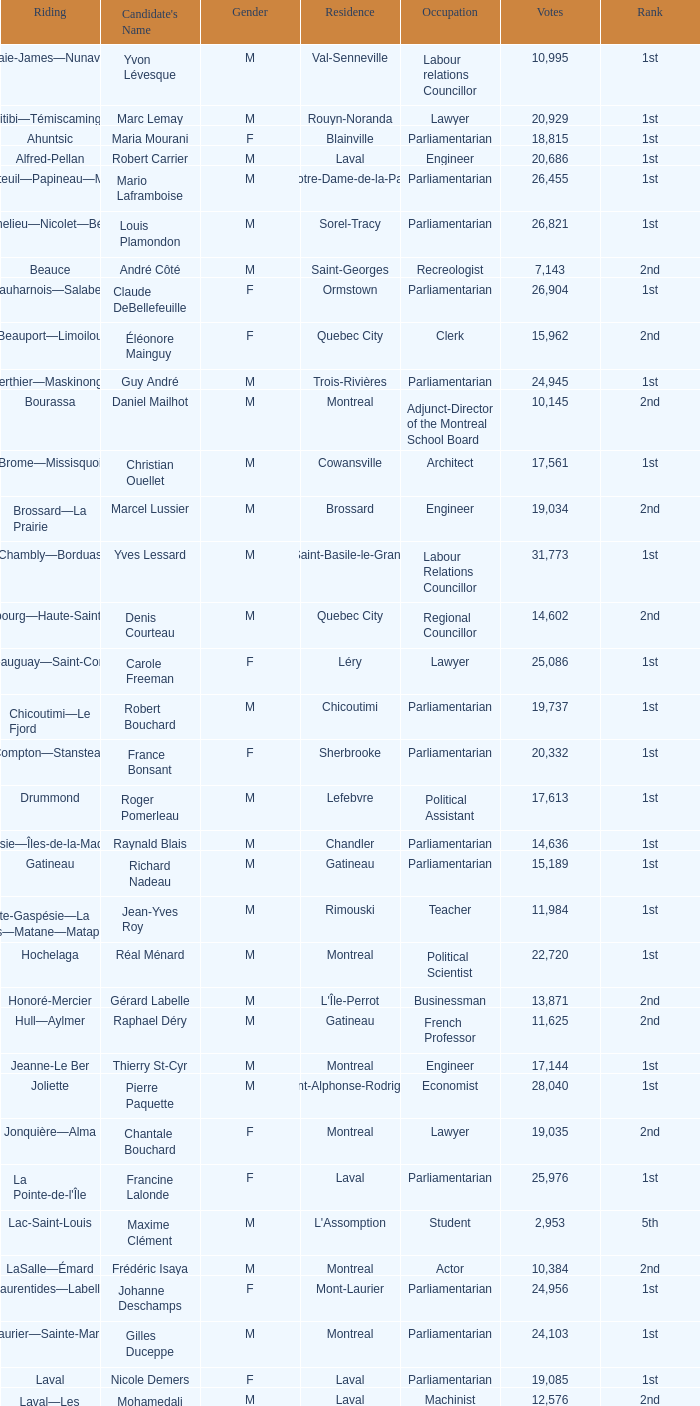What is the highest number of votes for the French Professor? 11625.0. 